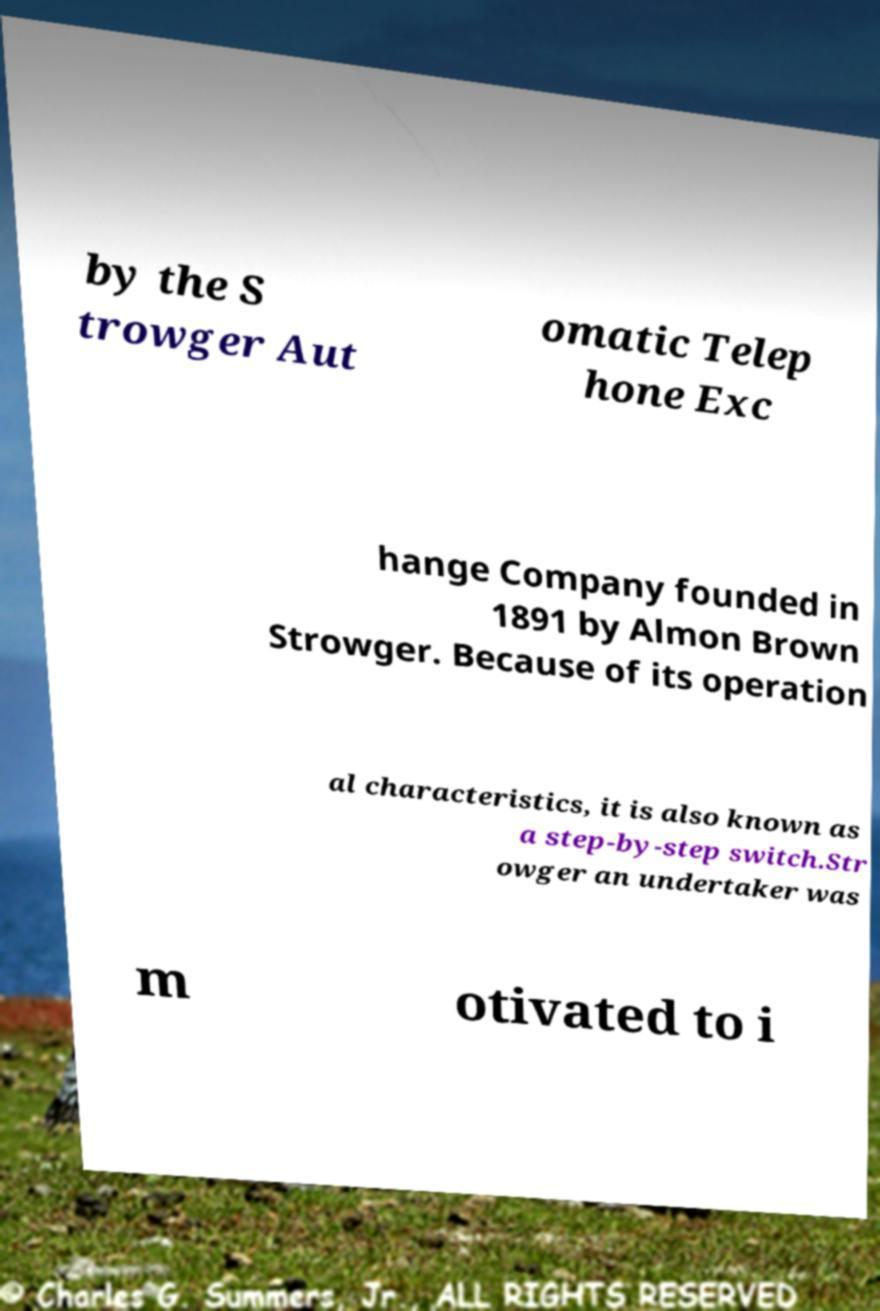There's text embedded in this image that I need extracted. Can you transcribe it verbatim? by the S trowger Aut omatic Telep hone Exc hange Company founded in 1891 by Almon Brown Strowger. Because of its operation al characteristics, it is also known as a step-by-step switch.Str owger an undertaker was m otivated to i 